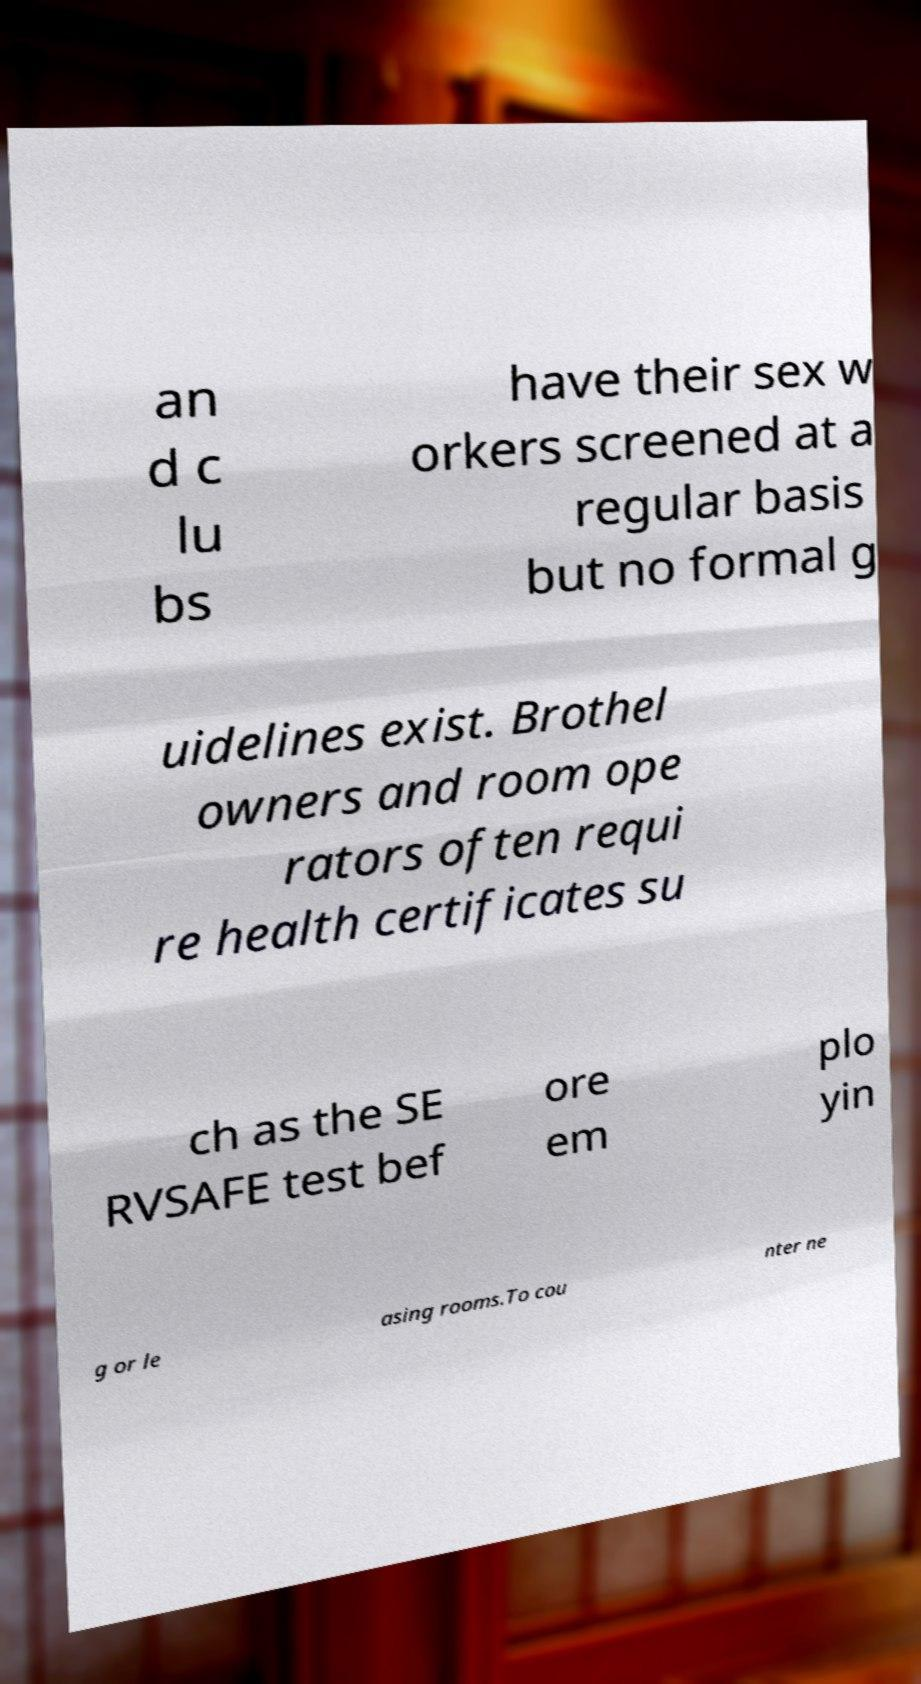Could you assist in decoding the text presented in this image and type it out clearly? an d c lu bs have their sex w orkers screened at a regular basis but no formal g uidelines exist. Brothel owners and room ope rators often requi re health certificates su ch as the SE RVSAFE test bef ore em plo yin g or le asing rooms.To cou nter ne 